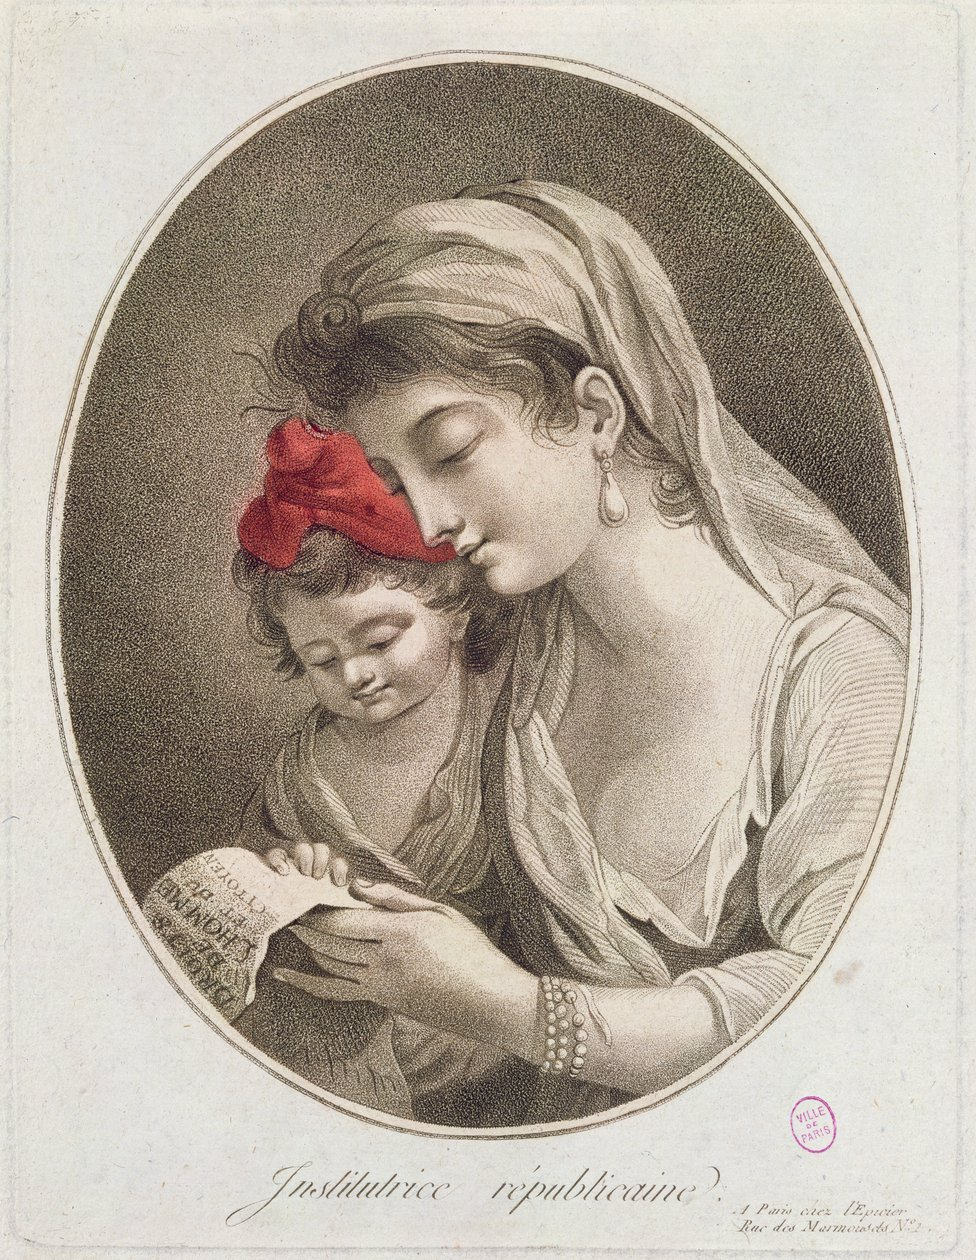Describe This image, titled "Institutrice républicaine" (Republican Schoolmistress), is a beautifully detailed, oval-shaped engraving from the French Revolution era. It depicts a young woman, dressed simply in the style of the time, teaching a small child to read. The woman, likely a teacher, wears her hair covered in a headscarf and adorned with a single earring. Her gaze is fixed on the child, a tender expression softening her features.

The child, bundled in simple clothes, sits attentively, holding a piece of paper that reads "RÉPUBLICAINE FRANÇAISE," a clear nod to the revolutionary government of the time. The child's focus is entirely on the woman, highlighting the trust and bond between them. 

The engraver skillfully uses light and shadow to create depth and realism, particularly in the folds of the woman's clothing and the gentle curves of their faces. The overall message is one of education, nurturing, and the hope for a brighter future for France through its children, symbolized by the child's focused study of the word "RÉPUBLICAINE." The image, while simple in composition, speaks volumes about the ideals and aspirations of the French Revolution. 